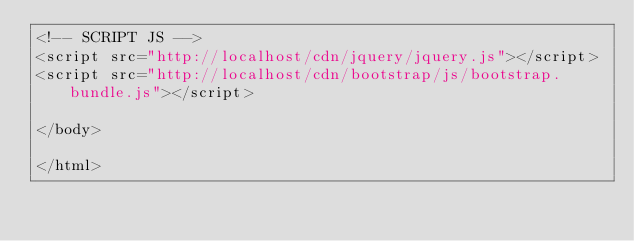Convert code to text. <code><loc_0><loc_0><loc_500><loc_500><_PHP_><!-- SCRIPT JS -->
<script src="http://localhost/cdn/jquery/jquery.js"></script>
<script src="http://localhost/cdn/bootstrap/js/bootstrap.bundle.js"></script>

</body>

</html></code> 